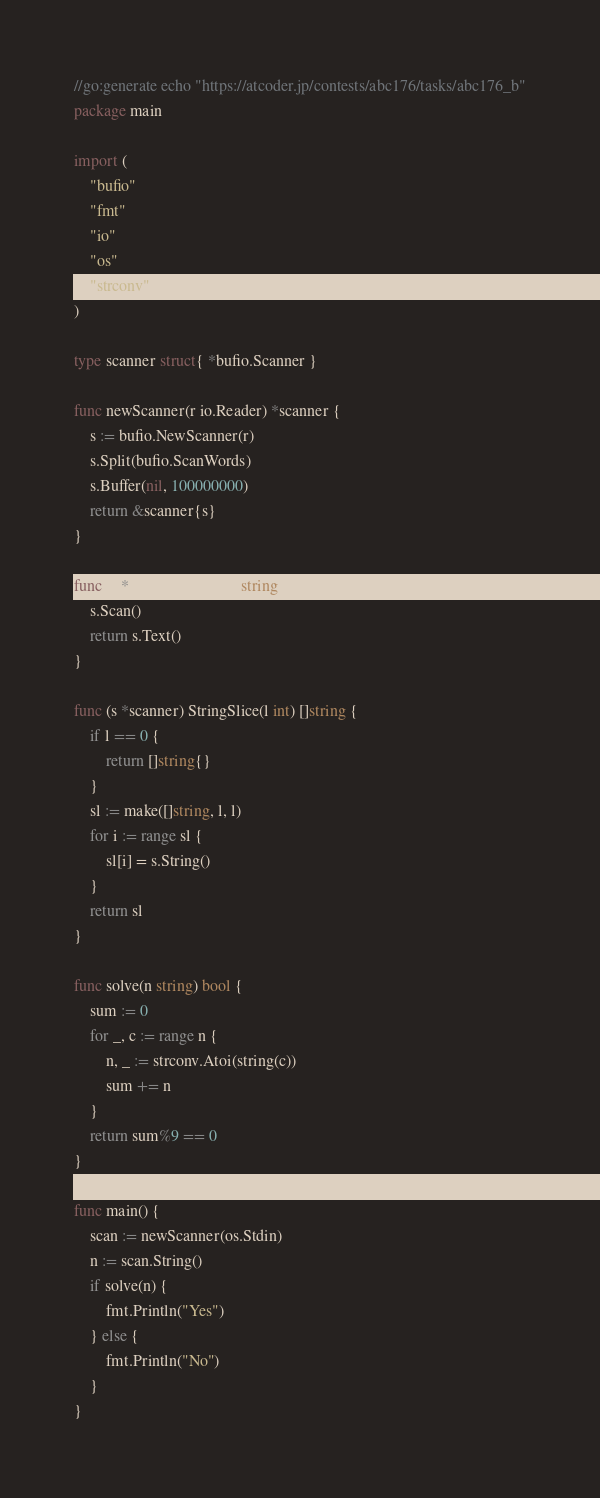<code> <loc_0><loc_0><loc_500><loc_500><_Go_>//go:generate echo "https://atcoder.jp/contests/abc176/tasks/abc176_b"
package main

import (
	"bufio"
	"fmt"
	"io"
	"os"
	"strconv"
)

type scanner struct{ *bufio.Scanner }

func newScanner(r io.Reader) *scanner {
	s := bufio.NewScanner(r)
	s.Split(bufio.ScanWords)
	s.Buffer(nil, 100000000)
	return &scanner{s}
}

func (s *scanner) String() string {
	s.Scan()
	return s.Text()
}

func (s *scanner) StringSlice(l int) []string {
	if l == 0 {
		return []string{}
	}
	sl := make([]string, l, l)
	for i := range sl {
		sl[i] = s.String()
	}
	return sl
}

func solve(n string) bool {
	sum := 0
	for _, c := range n {
		n, _ := strconv.Atoi(string(c))
		sum += n
	}
	return sum%9 == 0
}

func main() {
	scan := newScanner(os.Stdin)
	n := scan.String()
	if solve(n) {
		fmt.Println("Yes")
	} else {
		fmt.Println("No")
	}
}
</code> 